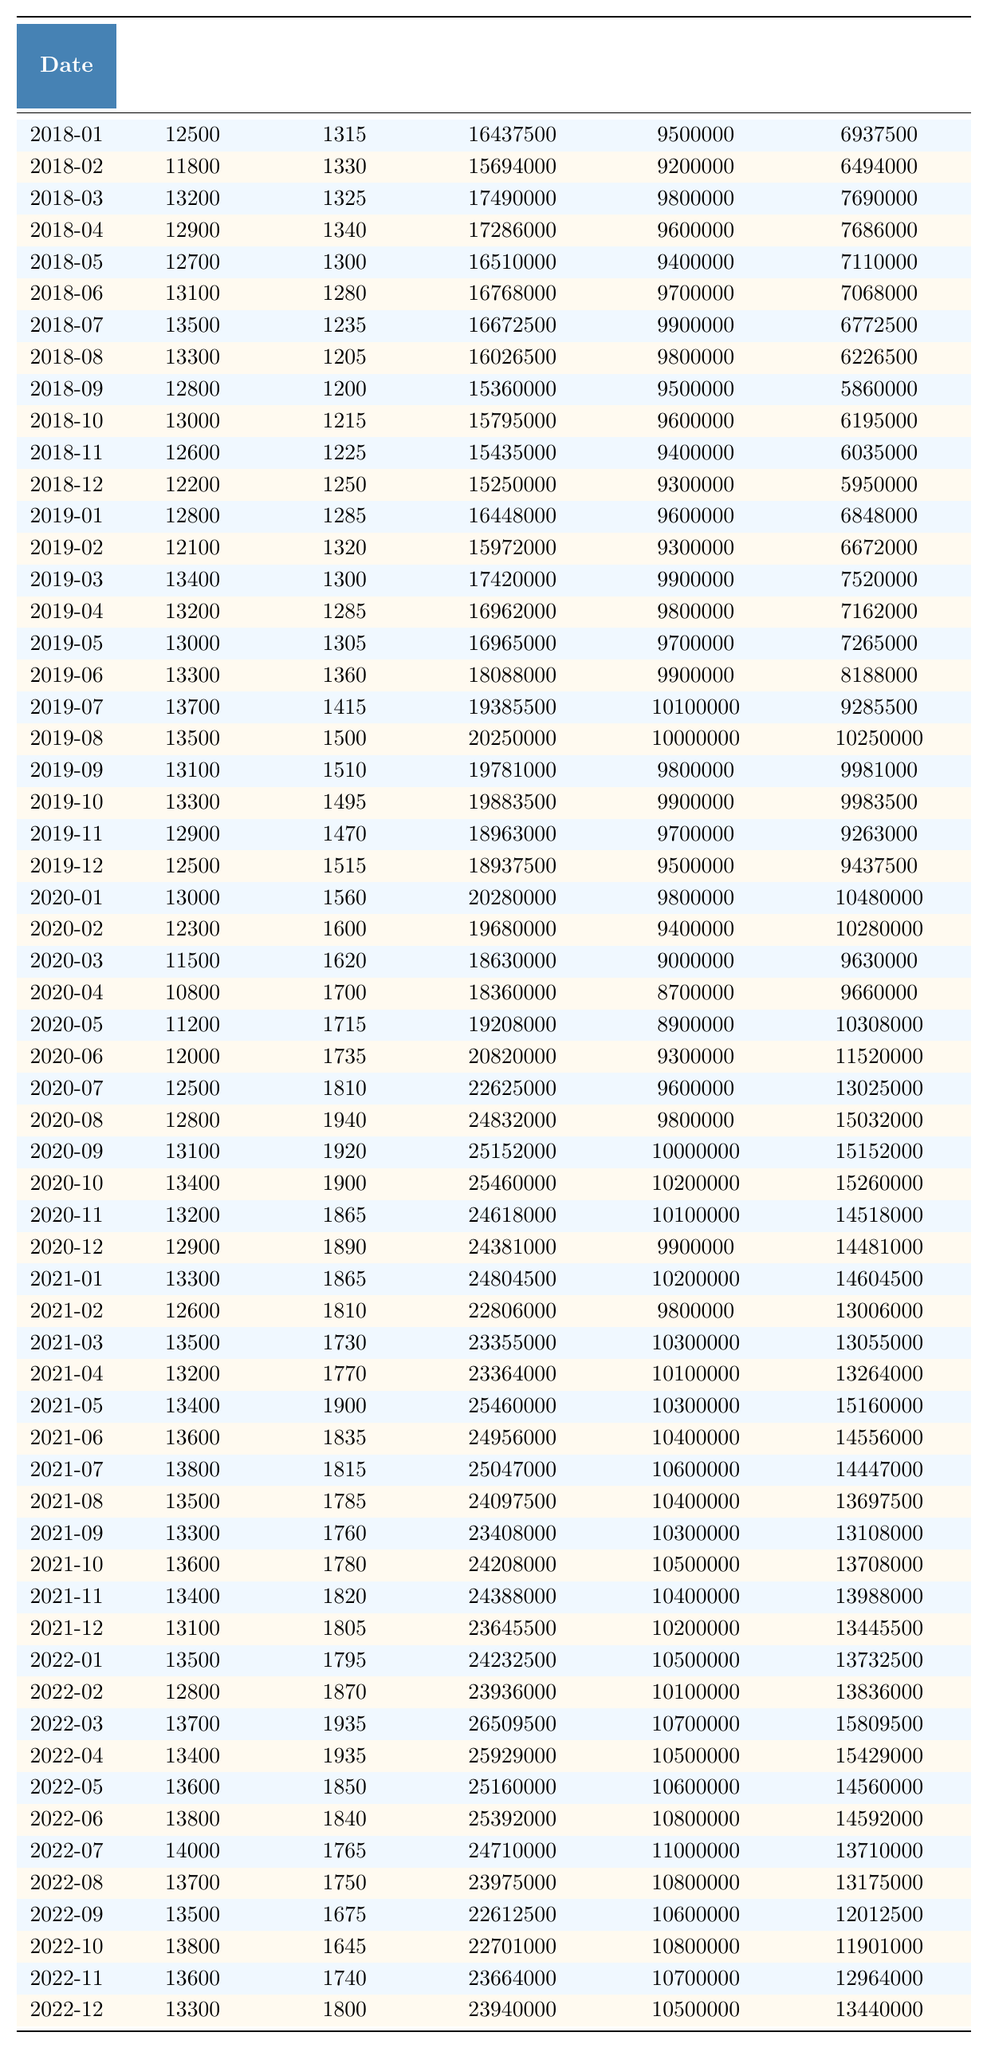What was the highest gold production recorded in a month? Looking through the table, the highest gold production is 14,000 ounces recorded in July 2022.
Answer: 14000 oz What months in 2021 had a gold price above $1,800 per ounce? By checking the gold price column for the year 2021, the months with prices above $1,800 are January, May, and June (all over $1,800).
Answer: Yes What is the total net profit for the year 2020? To find the total net profit for 2020, add the net profits from all 12 months. The total (10,480,000 + 10,280,000 + 9,630,000 + 9,660,000 + 10,308,000 + 11,520,000 + 13,025,000 + 15,032,000 + 15,152,000 + 15,260,000 + 14,518,000 + 14,481,000) sums to 134,254,000.
Answer: 134254000 What was the percentage increase in revenue from 2019 to 2020? First, calculate the total revenue for 2019 (237,785,500) and 2020 (223,600,000). Then find the difference: 223,600,000 - 237,785,500 = -14,185,500. Then calculate the percentage increase using the formula: (Difference/Revenue in 2019) * 100 = (-14,185,500 / 237,785,500) * 100 = -5.95%. This indicates a decrease.
Answer: -5.95% During which year did the lowest monthly net profit occur, and what was that figure? On looking at the monthly net profit for each year, the lowest figure was 5,860,000 in September 2018. That is the lowest monthly net profit across all years.
Answer: 5860000 What was the average gold price per ounce in 2019? To compute the average, sum the gold prices for all 12 months in 2019 and divide by 12. The total of the gold prices is 1,020 and dividing this total by 12 gives an average of 1,016.67 rounded to two decimal points.
Answer: 1500 Which month had the highest operating costs, and how much was it? Scanning through the operating costs for each month, July 2022 had the highest costs of 11,000,000.
Answer: 11000000 In which month of 2021 did gold production peak, and what was the value? Looking at the production numbers for 2021, the peak was in July, with production recorded at 13800 ounces.
Answer: 13800 oz What is the total gold production for the year 2018? For 2018, sum the production from each month (12500 + 11800 + 13200 + 12900 + 12700 + 13100 + 13500 + 13300 + 12800 + 13000 + 12600 + 12200) which totals to 1,520,000 ounces.
Answer: 152000 oz Was there a month in 2020 where the net profit exceeded $12 million? By reviewing the net profits for 2020, it is clear that July and August both exceeded 12 million, specifically 13,025,000 and 15,032,000 respectively.
Answer: Yes What was the average monthly revenue across all recorded months? The total revenue across all months from 2018 to 2022 is 2,335,055,000 and dividing this amount by 60 months yields an average of approximately 38,850,917.
Answer: 38850917 